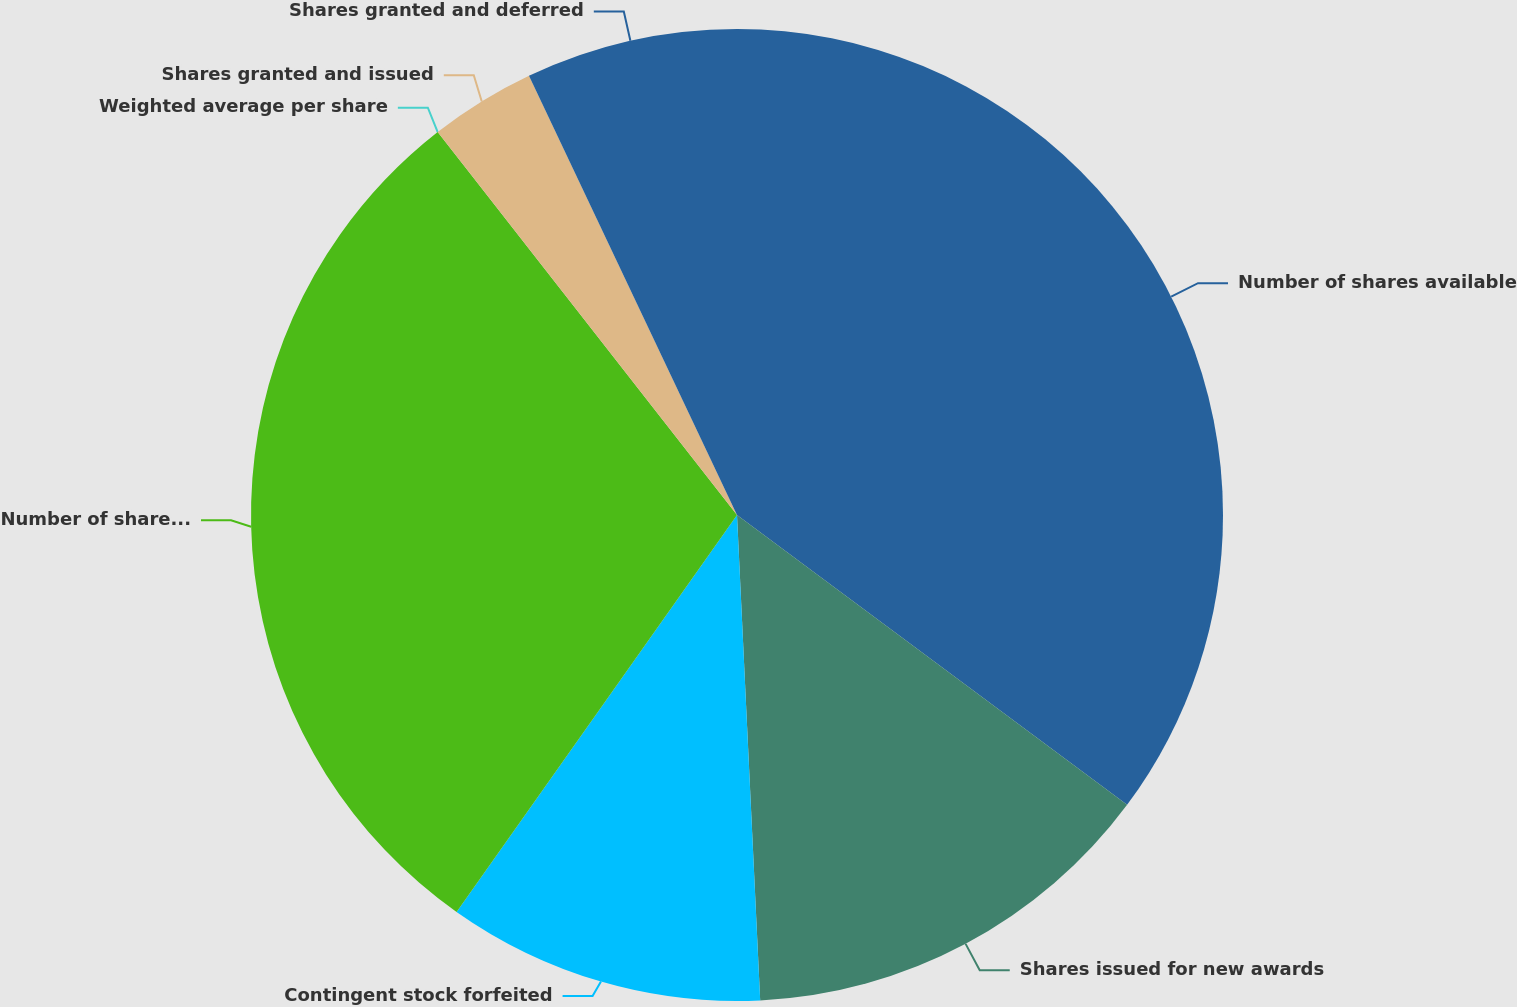<chart> <loc_0><loc_0><loc_500><loc_500><pie_chart><fcel>Number of shares available<fcel>Shares issued for new awards<fcel>Contingent stock forfeited<fcel>Number of shares available end<fcel>Weighted average per share<fcel>Shares granted and issued<fcel>Shares granted and deferred<nl><fcel>35.17%<fcel>14.07%<fcel>10.55%<fcel>29.65%<fcel>0.0%<fcel>3.52%<fcel>7.04%<nl></chart> 